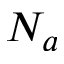<formula> <loc_0><loc_0><loc_500><loc_500>N _ { a }</formula> 